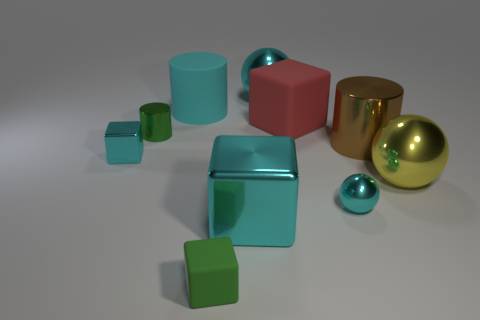The yellow shiny ball has what size?
Your answer should be very brief. Large. Do the green cube and the cylinder that is behind the large red matte thing have the same material?
Keep it short and to the point. Yes. Is there another large thing of the same shape as the large brown shiny object?
Offer a terse response. Yes. What material is the red thing that is the same size as the brown shiny cylinder?
Your response must be concise. Rubber. There is a cyan sphere that is behind the large red object; what size is it?
Keep it short and to the point. Large. Is the size of the cyan shiny block that is on the right side of the small green rubber block the same as the cyan metal cube that is behind the big yellow object?
Give a very brief answer. No. How many cyan things are the same material as the cyan cylinder?
Your answer should be very brief. 0. What color is the tiny cylinder?
Make the answer very short. Green. There is a brown metal cylinder; are there any small green rubber objects on the right side of it?
Keep it short and to the point. No. Is the color of the large rubber block the same as the small metal cylinder?
Keep it short and to the point. No. 